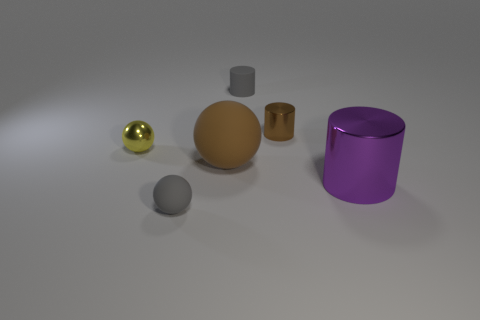Is the material of the big purple cylinder the same as the gray object that is behind the shiny sphere?
Provide a short and direct response. No. How many other objects are there of the same shape as the tiny yellow object?
Provide a short and direct response. 2. How many objects are either small gray rubber things that are behind the brown matte object or objects that are behind the brown metallic thing?
Offer a terse response. 1. What number of other objects are the same color as the big sphere?
Give a very brief answer. 1. Is the number of large metallic things left of the brown sphere less than the number of big cylinders that are behind the tiny gray rubber cylinder?
Offer a very short reply. No. How many purple metallic cylinders are there?
Make the answer very short. 1. Are there any other things that have the same material as the tiny yellow ball?
Your response must be concise. Yes. There is a gray object that is the same shape as the large brown object; what is its material?
Ensure brevity in your answer.  Rubber. Are there fewer big brown things that are to the right of the brown sphere than tiny purple things?
Offer a very short reply. No. There is a small gray matte thing to the left of the brown sphere; does it have the same shape as the tiny yellow thing?
Make the answer very short. Yes. 